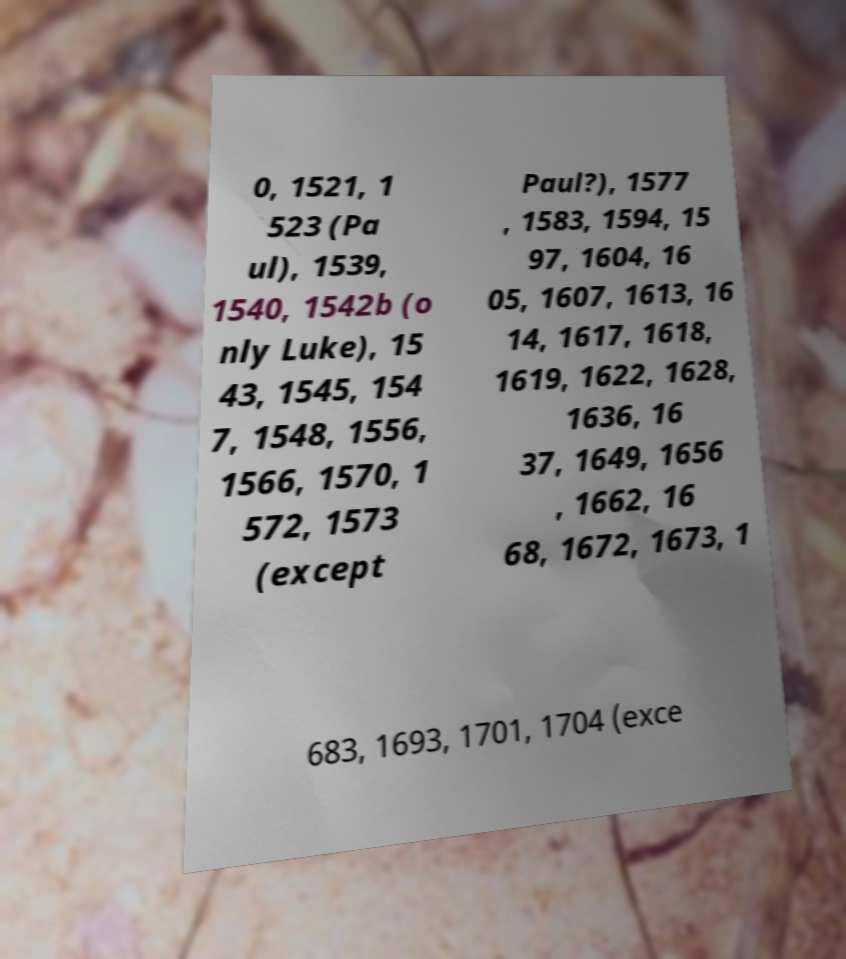Could you extract and type out the text from this image? 0, 1521, 1 523 (Pa ul), 1539, 1540, 1542b (o nly Luke), 15 43, 1545, 154 7, 1548, 1556, 1566, 1570, 1 572, 1573 (except Paul?), 1577 , 1583, 1594, 15 97, 1604, 16 05, 1607, 1613, 16 14, 1617, 1618, 1619, 1622, 1628, 1636, 16 37, 1649, 1656 , 1662, 16 68, 1672, 1673, 1 683, 1693, 1701, 1704 (exce 